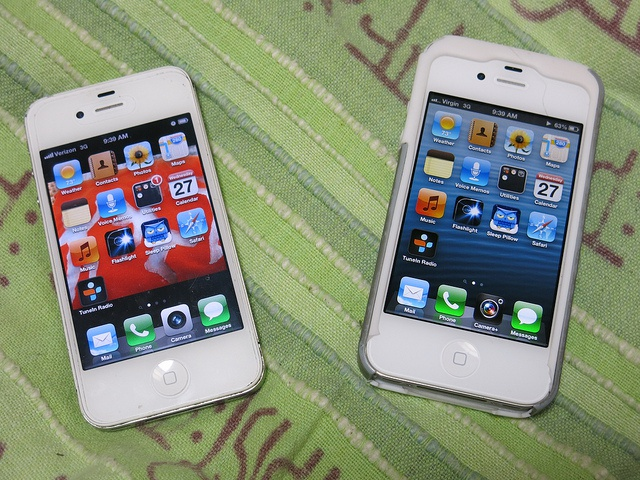Describe the objects in this image and their specific colors. I can see cell phone in olive, lightgray, black, darkgray, and navy tones and cell phone in olive, lightgray, black, darkgray, and brown tones in this image. 